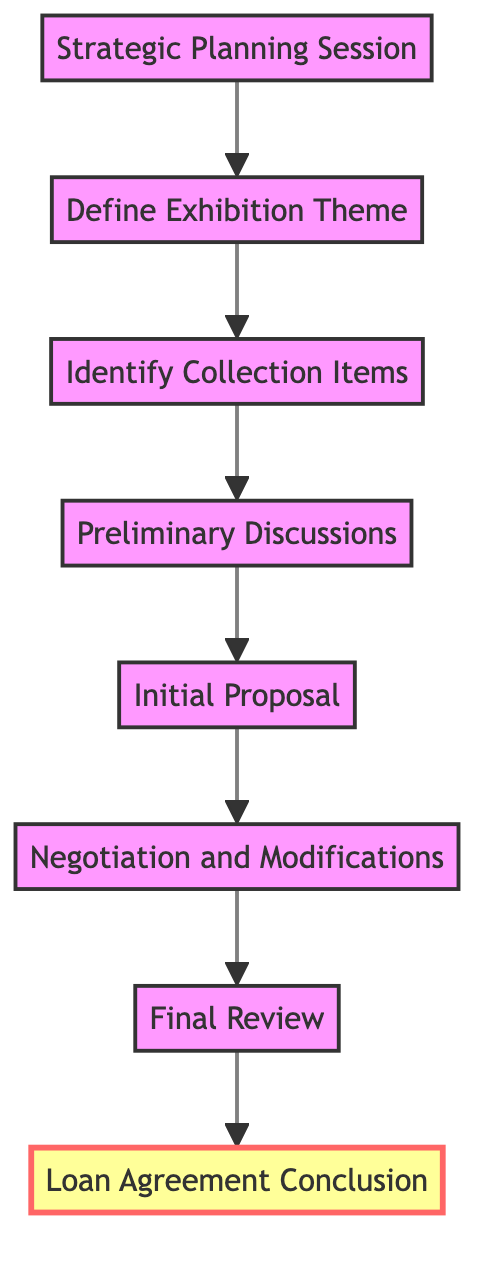What's the first step in the flowchart? The flowchart begins with "Strategic Planning Session," which is the first node in the diagram.
Answer: Strategic Planning Session How many total steps are present in the diagram? There are eight distinct steps represented in the flowchart, counting each node from the bottom to the top.
Answer: Eight What is the last step before the Loan Agreement Conclusion? The step prior to "Loan Agreement Conclusion" is "Final Review," which directly leads into the conclusion in the flow sequence.
Answer: Final Review Which step follows the Initial Proposal? "Negotiation and Modifications" is the immediate step that comes after "Initial Proposal" in the flow order.
Answer: Negotiation and Modifications What is the relationship between "Define Exhibition Theme" and "Identify Collection Items"? "Define Exhibition Theme" comes before "Identify Collection Items," indicating that the theme must be outlined prior to selecting items for the exhibition.
Answer: Sequential What occurs after "Preliminary Discussions"? After "Preliminary Discussions," the next step is "Initial Proposal," indicating that proposals are drafted based on the discussions held.
Answer: Initial Proposal Which steps collectively focus on finalizing the terms of the loan agreement? "Negotiation and Modifications," "Final Review," and "Loan Agreement Conclusion" work together to finalize the terms of the loan agreement.
Answer: Three steps What is the purpose of the "Strategic Planning Session"? The objective of the "Strategic Planning Session" is to outline exhibition goals through planning sessions with curators and advisors.
Answer: Outline exhibition goals Which node serves as a transition from planning to action in the loan agreement process? "Define Exhibition Theme" acts as the transition point from strategic planning to actionable steps in the loan agreement process.
Answer: Define Exhibition Theme 